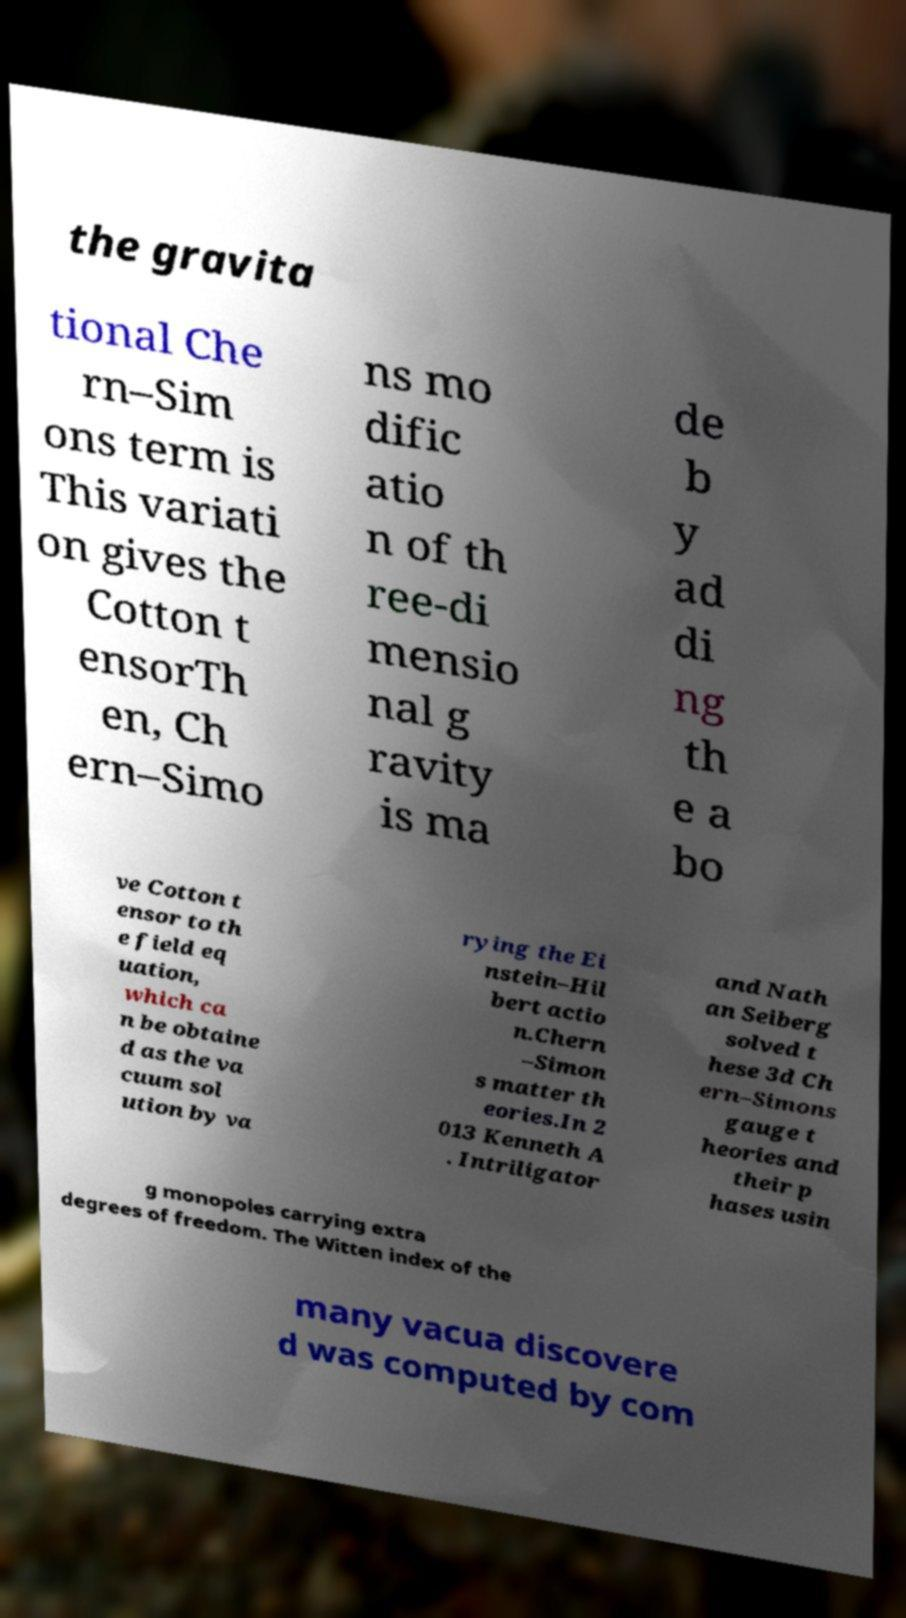Can you read and provide the text displayed in the image?This photo seems to have some interesting text. Can you extract and type it out for me? the gravita tional Che rn–Sim ons term is This variati on gives the Cotton t ensorTh en, Ch ern–Simo ns mo dific atio n of th ree-di mensio nal g ravity is ma de b y ad di ng th e a bo ve Cotton t ensor to th e field eq uation, which ca n be obtaine d as the va cuum sol ution by va rying the Ei nstein–Hil bert actio n.Chern –Simon s matter th eories.In 2 013 Kenneth A . Intriligator and Nath an Seiberg solved t hese 3d Ch ern–Simons gauge t heories and their p hases usin g monopoles carrying extra degrees of freedom. The Witten index of the many vacua discovere d was computed by com 